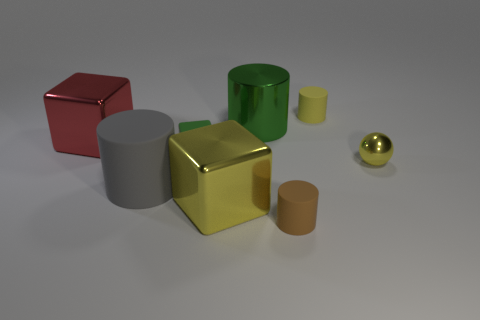Subtract all brown rubber cylinders. How many cylinders are left? 3 Add 2 small green matte objects. How many objects exist? 10 Subtract all blocks. How many objects are left? 5 Subtract 1 blocks. How many blocks are left? 2 Add 2 matte blocks. How many matte blocks exist? 3 Subtract all red blocks. How many blocks are left? 2 Subtract 0 gray balls. How many objects are left? 8 Subtract all blue spheres. Subtract all red cubes. How many spheres are left? 1 Subtract all small cyan matte objects. Subtract all matte blocks. How many objects are left? 7 Add 5 large red metal objects. How many large red metal objects are left? 6 